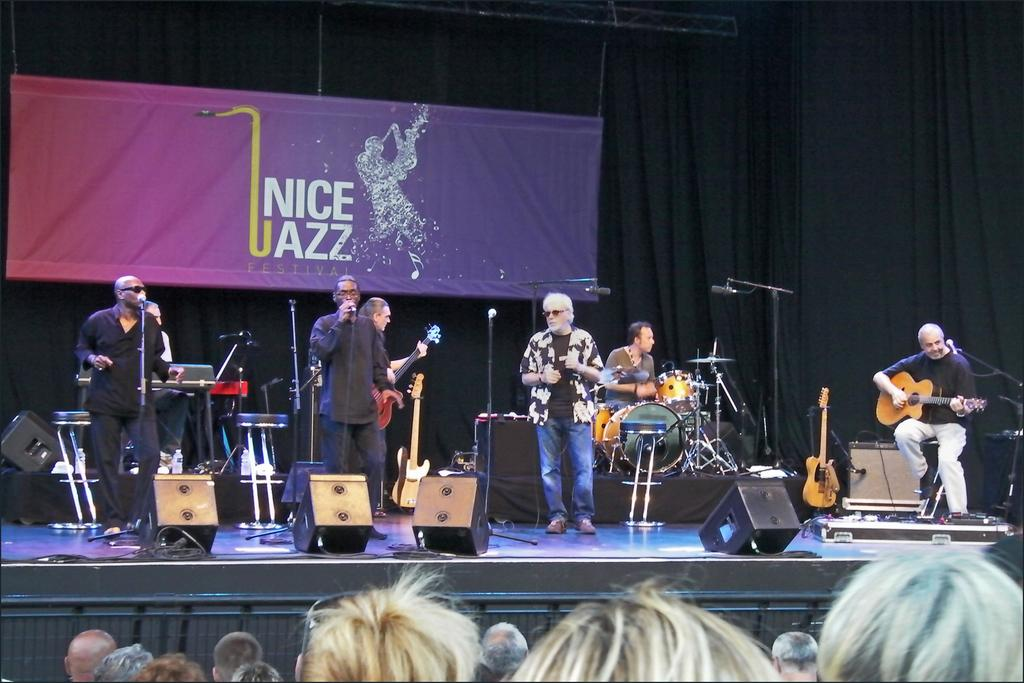What is happening on the stage in the image? There are people on the stage, and they are performing. What are the performers doing on stage? The performers are playing musical instruments. What can be seen behind the performers on stage? There is a banner behind the performers. Who is present in front of the stage? There are people in front of the stage. Can you see any veins in the brass instruments being played by the performers? There is no mention of brass instruments in the image, and even if there were, it would not be possible to see veins in them. 